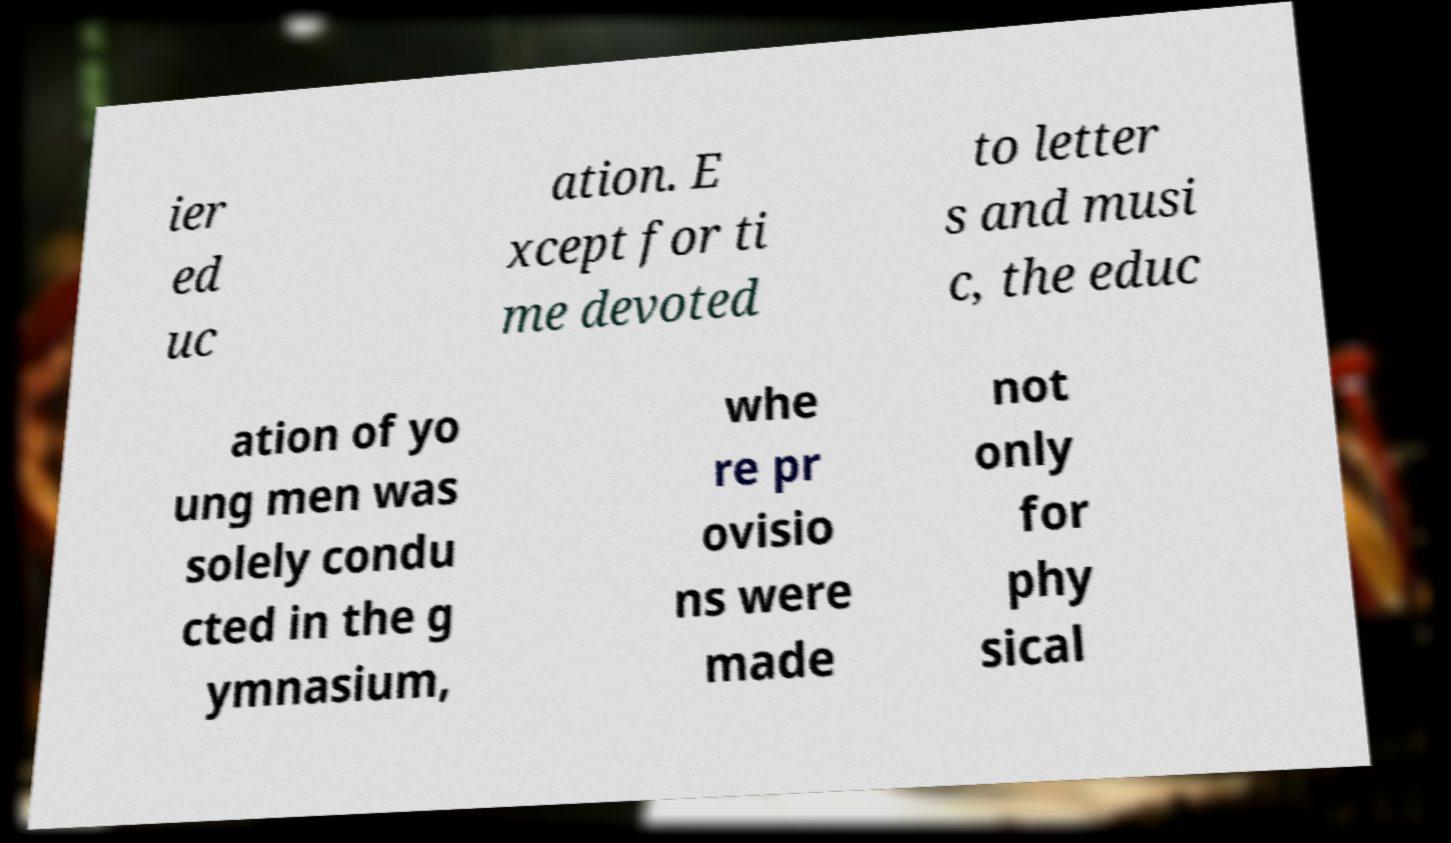Can you read and provide the text displayed in the image?This photo seems to have some interesting text. Can you extract and type it out for me? ier ed uc ation. E xcept for ti me devoted to letter s and musi c, the educ ation of yo ung men was solely condu cted in the g ymnasium, whe re pr ovisio ns were made not only for phy sical 